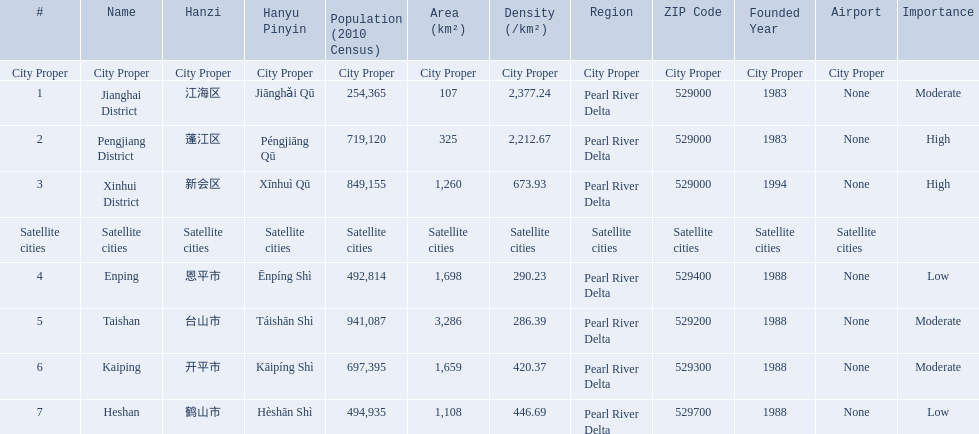What city propers are listed? Jianghai District, Pengjiang District, Xinhui District. Which hast he smallest area in km2? Jianghai District. 